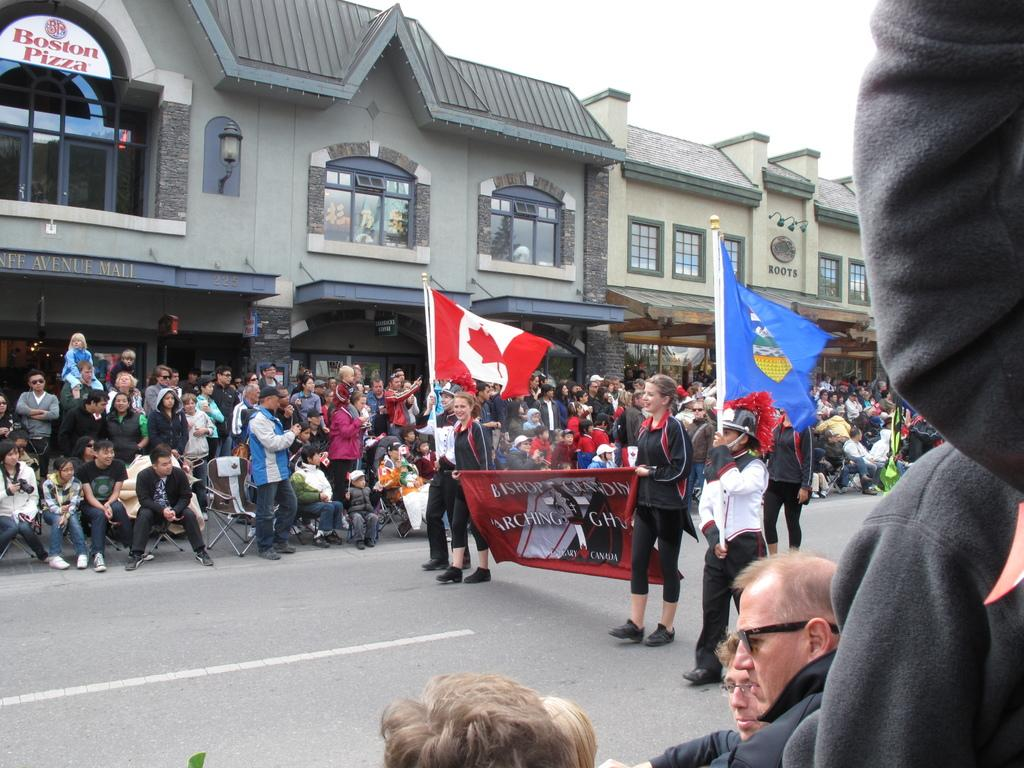What type of structures can be seen in the image? There are buildings in the image. What symbols are present in the image? There are flags and a banner in the image. Who or what is present in the image besides the buildings and symbols? There is a group of people in the image. What is visible at the top of the image? The sky is visible at the top of the image. What type of vacation is being advertised on the banner in the image? There is no information about a vacation in the image; it only features buildings, flags, a banner, a group of people, and the sky. What is the group of people wishing for in the image? There is no indication of a wish or any specific desire in the image; it simply shows a group of people in the presence of buildings, flags, a banner, and the sky. 